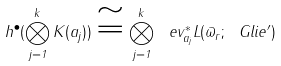Convert formula to latex. <formula><loc_0><loc_0><loc_500><loc_500>h ^ { \bullet } ( \bigotimes _ { j = 1 } ^ { k } K ( a _ { j } ) ) \cong \bigotimes _ { j = 1 } ^ { k } \ e v _ { a _ { j } } ^ { * } L ( \varpi _ { r } ; \ G l i e ^ { \prime } )</formula> 